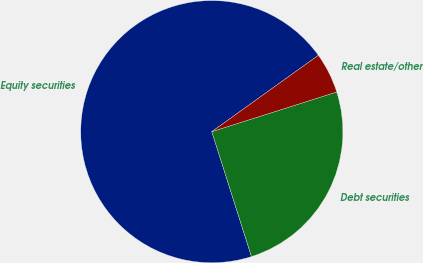<chart> <loc_0><loc_0><loc_500><loc_500><pie_chart><fcel>Equity securities<fcel>Debt securities<fcel>Real estate/other<nl><fcel>70.0%<fcel>25.0%<fcel>5.0%<nl></chart> 